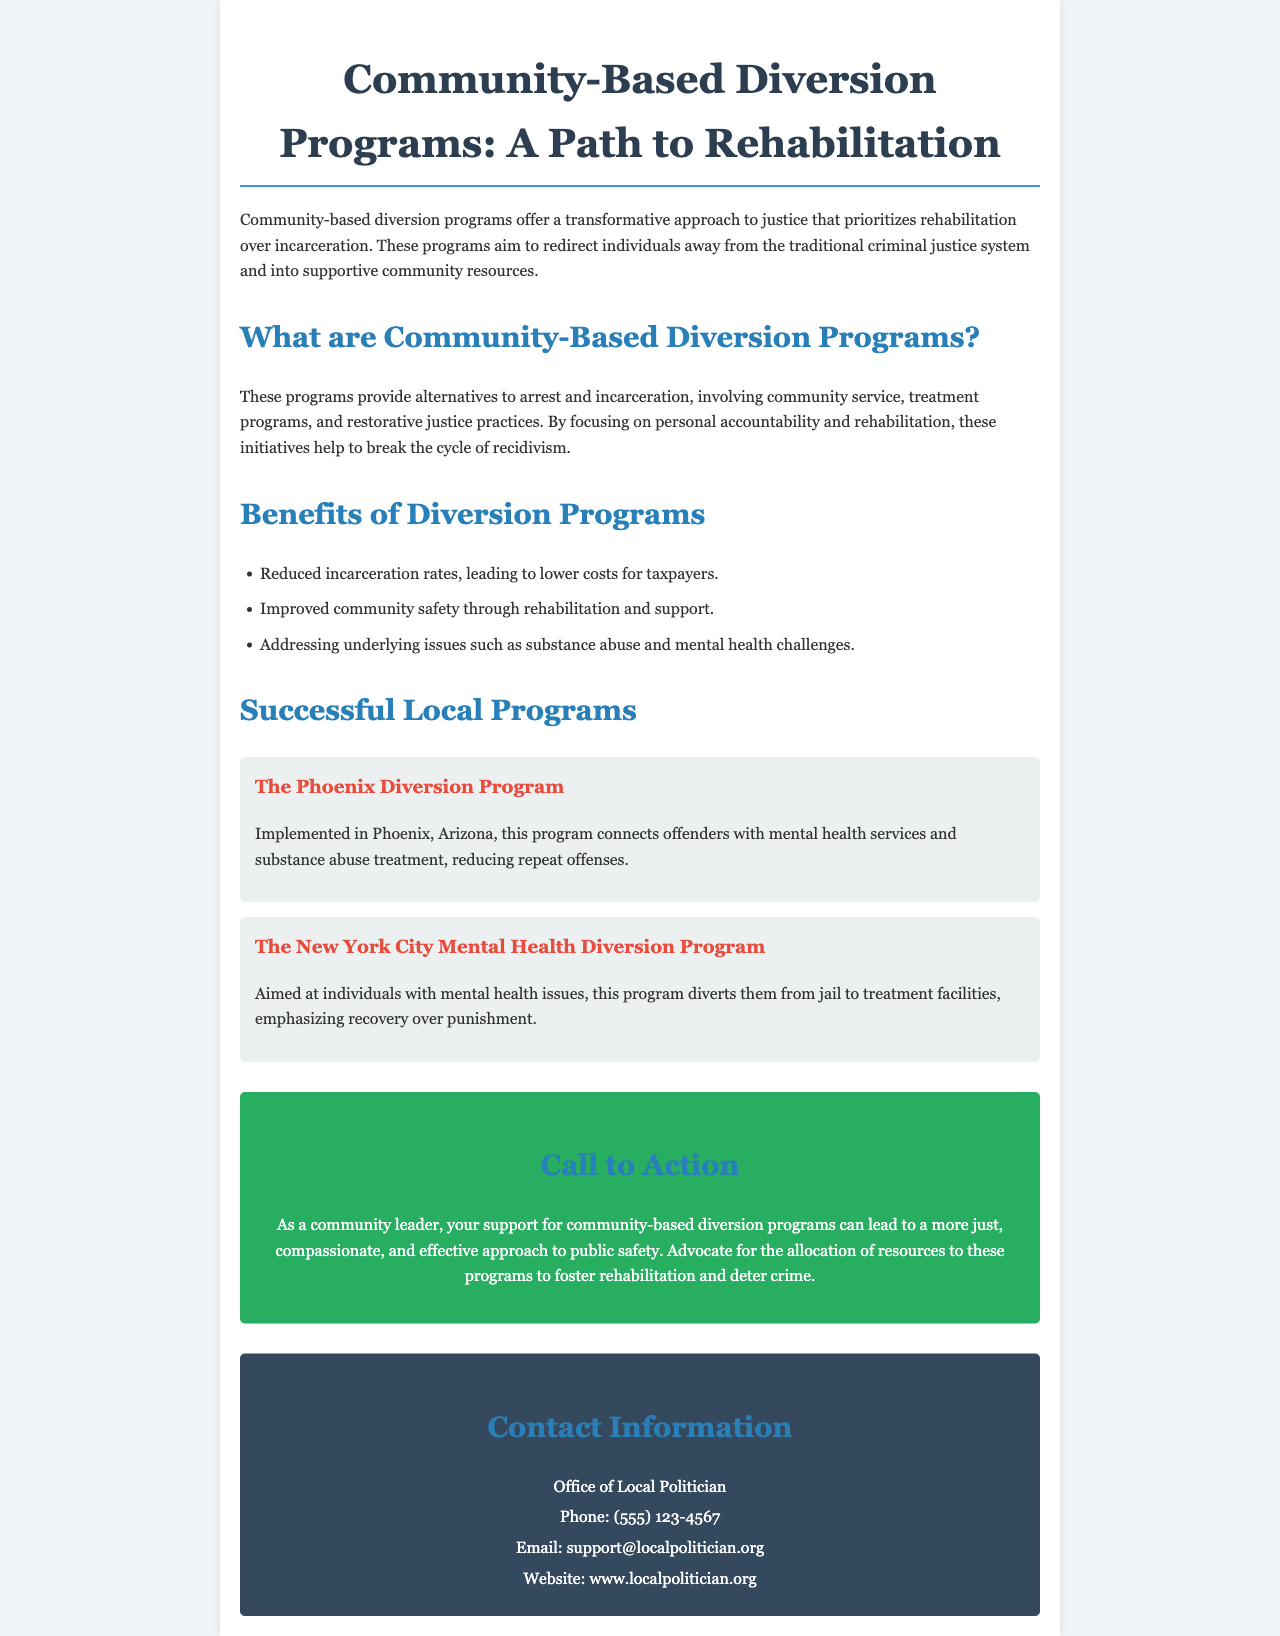What are community-based diversion programs? Community-based diversion programs are initiatives that provide alternatives to arrest and incarceration, focusing on rehabilitation within the community.
Answer: Alternatives to arrest and incarceration What is the main goal of these programs? The document states that these programs aim to redirect individuals away from the traditional criminal justice system into supportive community resources.
Answer: Rehabilitation What is one benefit of diversion programs mentioned in the brochure? The brochure lists several benefits; one specific benefit is reduced incarceration rates, leading to lower costs for taxpayers.
Answer: Reduced incarceration rates Name one successful local program highlighted. The document provides examples of local programs, one of which is the Phoenix Diversion Program.
Answer: The Phoenix Diversion Program What type of services does the Phoenix Diversion Program connect offenders with? The brochure indicates that the Phoenix Diversion Program connects offenders with mental health services and substance abuse treatment.
Answer: Mental health services and substance abuse treatment What is emphasized in the New York City Mental Health Diversion Program? The brochure explains that this program emphasizes recovery over punishment for individuals with mental health issues.
Answer: Recovery over punishment How can community leaders support diversion programs? The brochure urges community leaders to advocate for the allocation of resources to foster rehabilitation and deter crime.
Answer: Advocate for resources What is the contact email for the Office of Local Politician? The document provides contact information, including an email address for the Office of Local Politician.
Answer: support@localpolitician.org What does the "Call to Action" section encourage? This section calls on community leaders to support community-based diversion programs to create a more effective public safety approach.
Answer: Support community-based diversion programs 